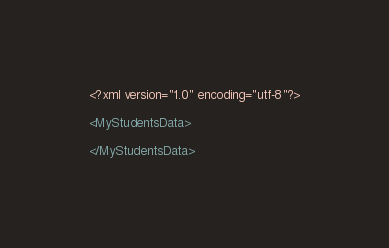Convert code to text. <code><loc_0><loc_0><loc_500><loc_500><_XML_><?xml version="1.0" encoding="utf-8"?>

<MyStudentsData>

</MyStudentsData></code> 